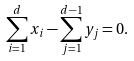<formula> <loc_0><loc_0><loc_500><loc_500>\sum _ { i = 1 } ^ { d } x _ { i } - \sum _ { j = 1 } ^ { d - 1 } y _ { j } = 0 .</formula> 